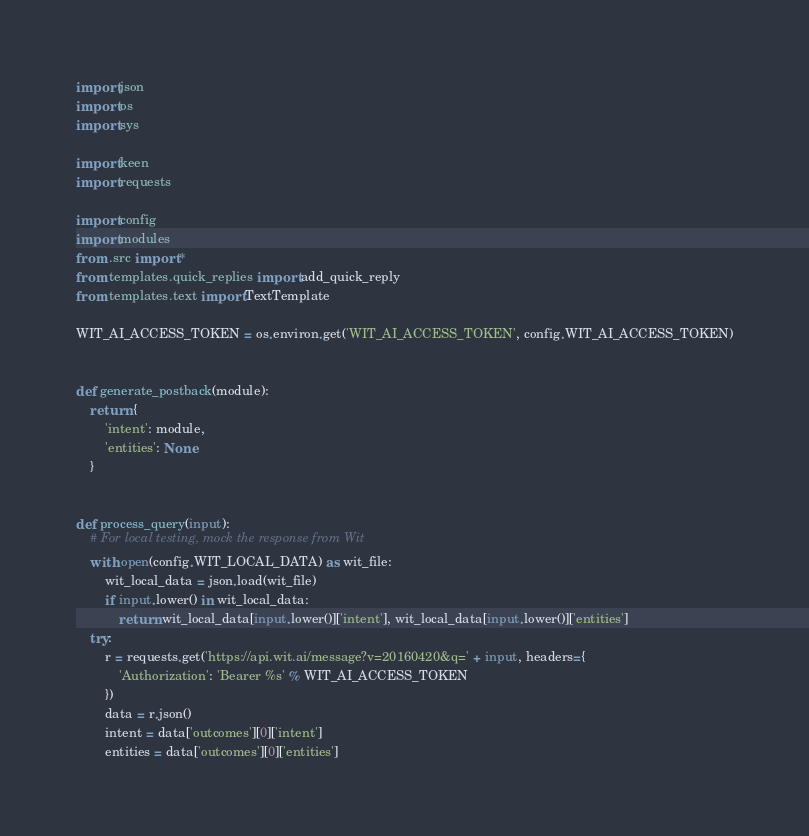<code> <loc_0><loc_0><loc_500><loc_500><_Python_>import json
import os
import sys

import keen
import requests

import config
import modules
from .src import *
from templates.quick_replies import add_quick_reply
from templates.text import TextTemplate

WIT_AI_ACCESS_TOKEN = os.environ.get('WIT_AI_ACCESS_TOKEN', config.WIT_AI_ACCESS_TOKEN)


def generate_postback(module):
    return {
        'intent': module,
        'entities': None
    }


def process_query(input):
    # For local testing, mock the response from Wit
    with open(config.WIT_LOCAL_DATA) as wit_file:
        wit_local_data = json.load(wit_file)
        if input.lower() in wit_local_data:
            return wit_local_data[input.lower()]['intent'], wit_local_data[input.lower()]['entities']
    try:
        r = requests.get('https://api.wit.ai/message?v=20160420&q=' + input, headers={
            'Authorization': 'Bearer %s' % WIT_AI_ACCESS_TOKEN
        })
        data = r.json()
        intent = data['outcomes'][0]['intent']
        entities = data['outcomes'][0]['entities']</code> 